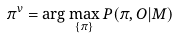<formula> <loc_0><loc_0><loc_500><loc_500>\pi ^ { v } = \arg \max _ { \{ \pi \} } P ( \pi , O | M )</formula> 